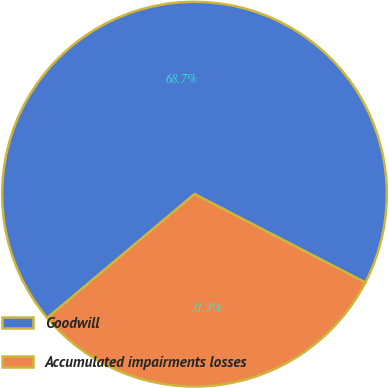<chart> <loc_0><loc_0><loc_500><loc_500><pie_chart><fcel>Goodwill<fcel>Accumulated impairments losses<nl><fcel>68.73%<fcel>31.27%<nl></chart> 